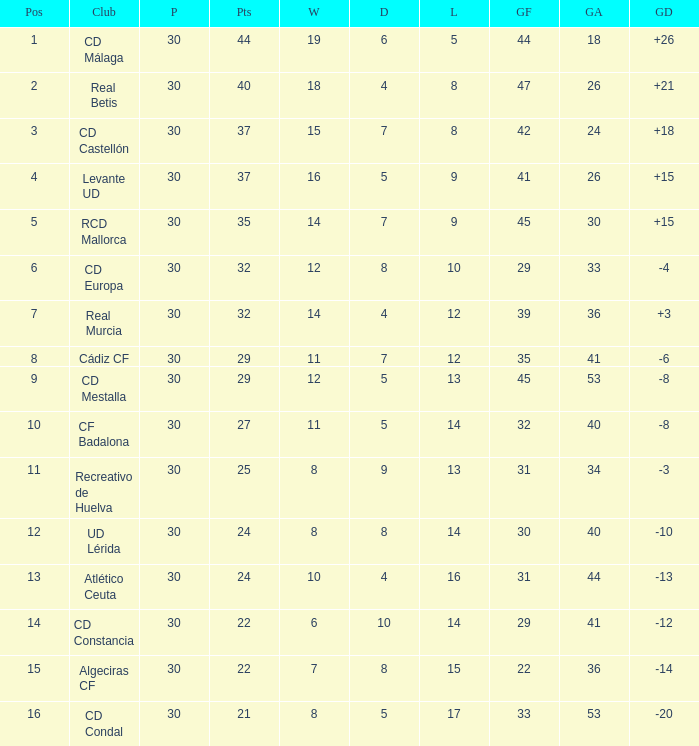What is the losses when the goal difference is larger than 26? None. 